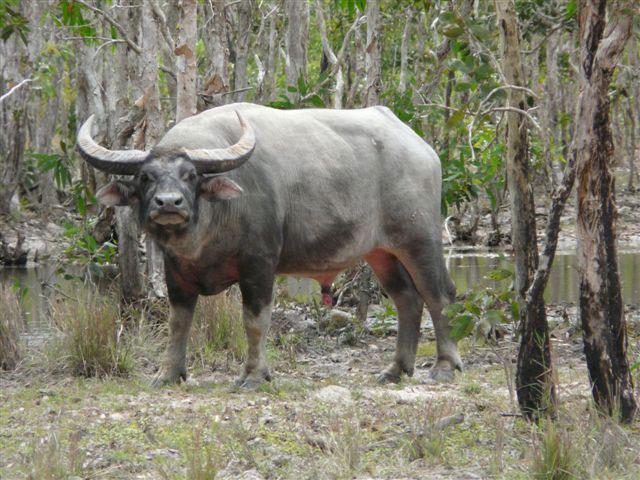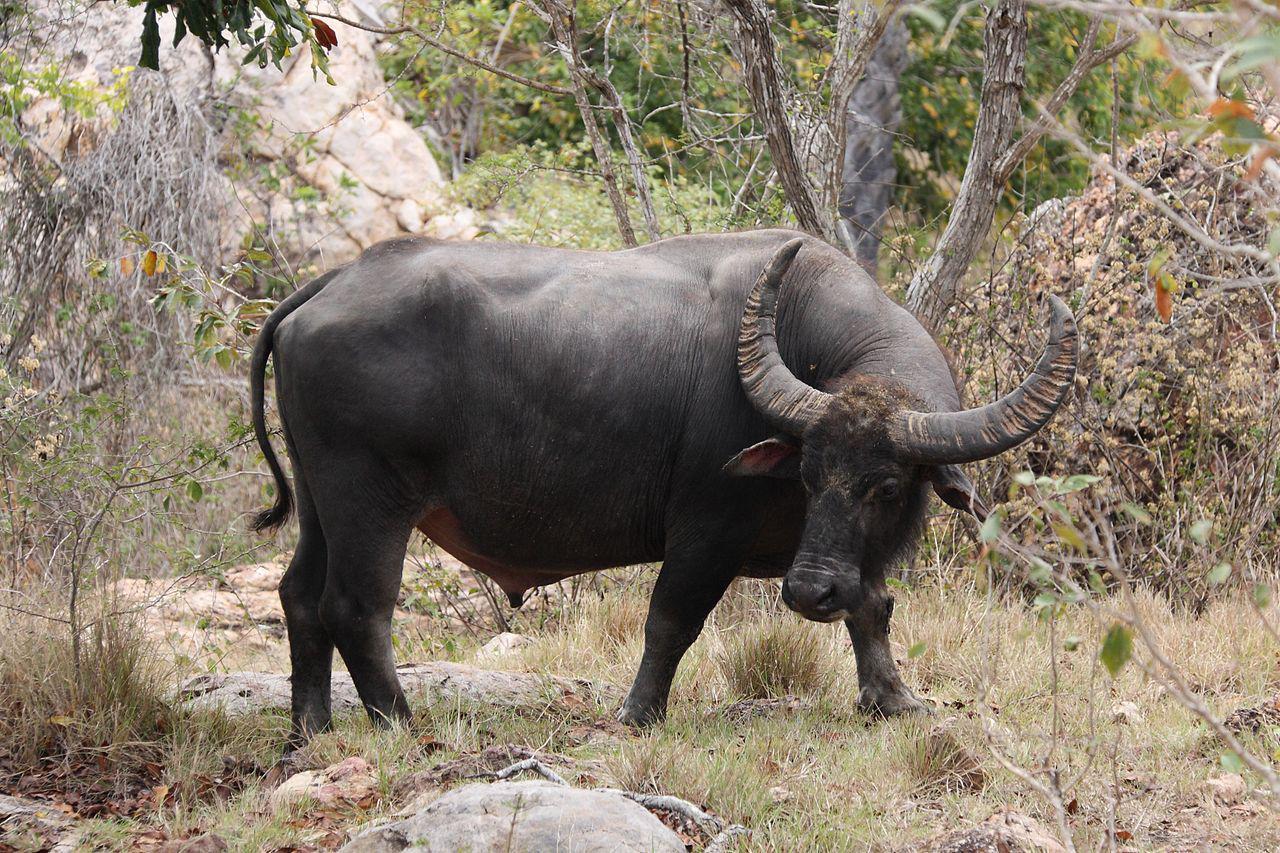The first image is the image on the left, the second image is the image on the right. For the images displayed, is the sentence "The oxen in the foreground of the two images have their bodies facing each other." factually correct? Answer yes or no. No. 